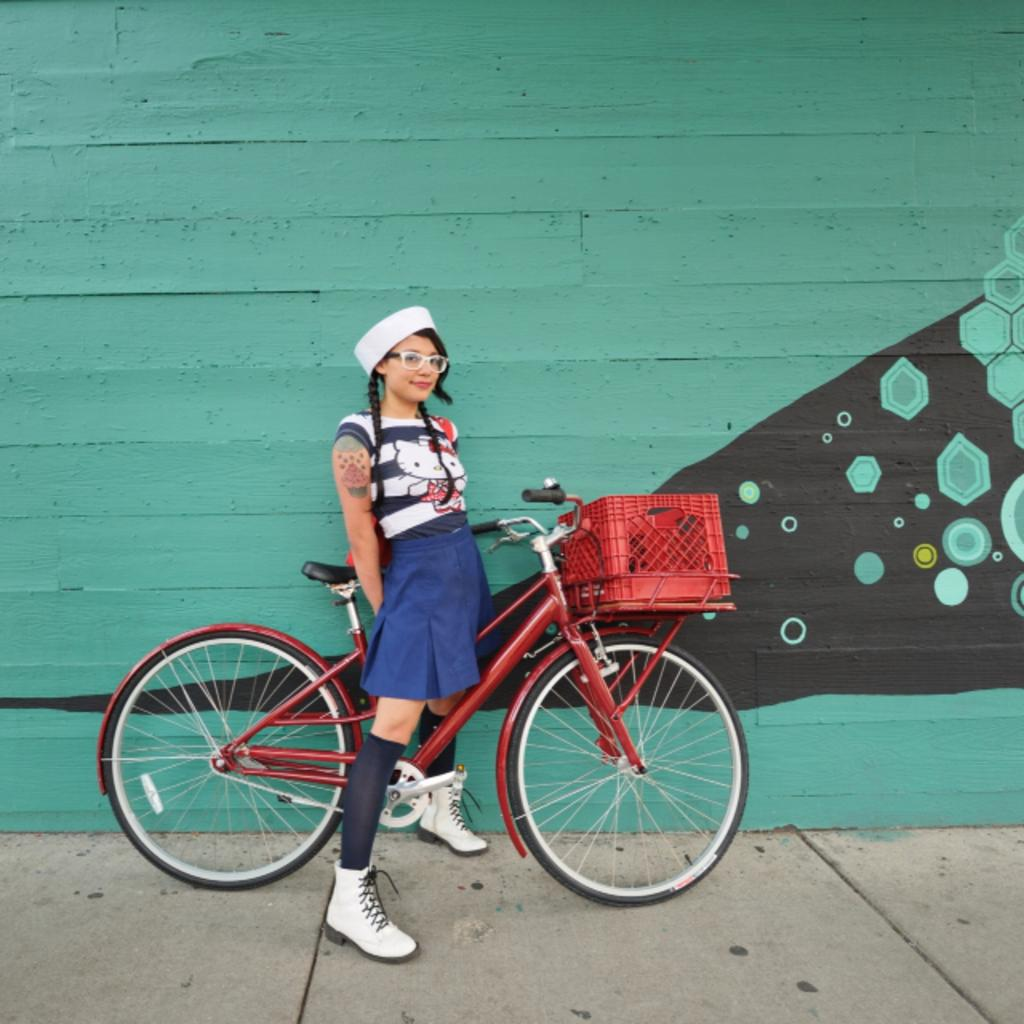Who is the main subject in the image? There is a woman in the image. What is the woman doing in the image? The woman is posing for a photo. What is the woman holding or standing near in the image? The woman is with a bicycle. What accessories is the woman wearing in the image? The woman is wearing a cap and spectacles. What can be seen in the background of the image? There is a wall in the background of the image. What type of bone can be seen in the woman's hand in the image? There is no bone visible in the woman's hand in the image. What is the plot of the story being told in the image? The image is not a story, so there is no plot to describe. 